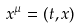<formula> <loc_0><loc_0><loc_500><loc_500>x ^ { \mu } = ( t , x )</formula> 